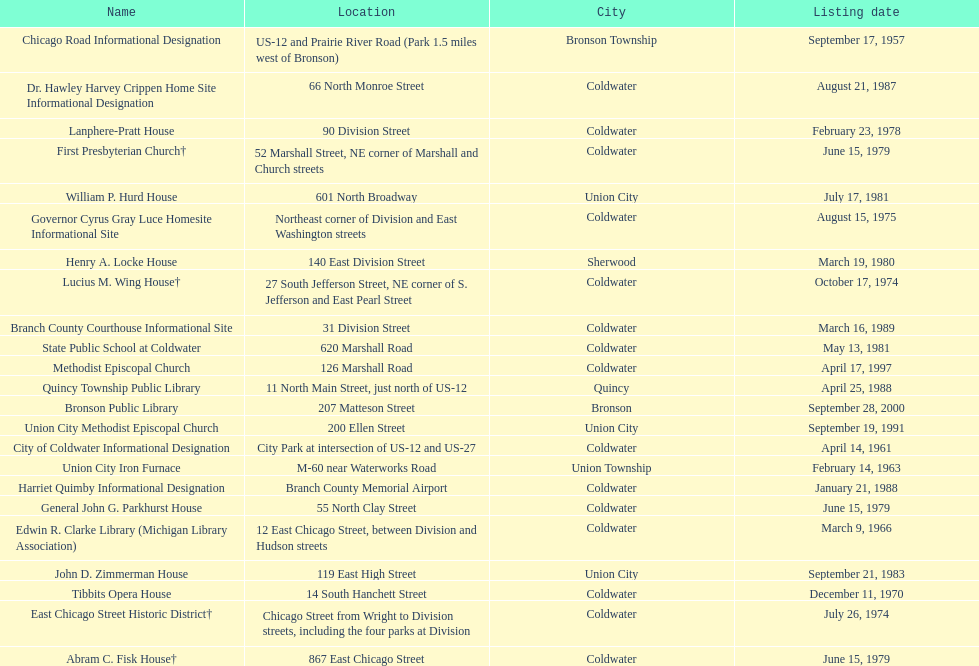Can you give me this table as a dict? {'header': ['Name', 'Location', 'City', 'Listing date'], 'rows': [['Chicago Road Informational Designation', 'US-12 and Prairie River Road (Park 1.5 miles west of Bronson)', 'Bronson Township', 'September 17, 1957'], ['Dr. Hawley Harvey Crippen Home Site Informational Designation', '66 North Monroe Street', 'Coldwater', 'August 21, 1987'], ['Lanphere-Pratt House', '90 Division Street', 'Coldwater', 'February 23, 1978'], ['First Presbyterian Church†', '52 Marshall Street, NE corner of Marshall and Church streets', 'Coldwater', 'June 15, 1979'], ['William P. Hurd House', '601 North Broadway', 'Union City', 'July 17, 1981'], ['Governor Cyrus Gray Luce Homesite Informational Site', 'Northeast corner of Division and East Washington streets', 'Coldwater', 'August 15, 1975'], ['Henry A. Locke House', '140 East Division Street', 'Sherwood', 'March 19, 1980'], ['Lucius M. Wing House†', '27 South Jefferson Street, NE corner of S. Jefferson and East Pearl Street', 'Coldwater', 'October 17, 1974'], ['Branch County Courthouse Informational Site', '31 Division Street', 'Coldwater', 'March 16, 1989'], ['State Public School at Coldwater', '620 Marshall Road', 'Coldwater', 'May 13, 1981'], ['Methodist Episcopal Church', '126 Marshall Road', 'Coldwater', 'April 17, 1997'], ['Quincy Township Public Library', '11 North Main Street, just north of US-12', 'Quincy', 'April 25, 1988'], ['Bronson Public Library', '207 Matteson Street', 'Bronson', 'September 28, 2000'], ['Union City Methodist Episcopal Church', '200 Ellen Street', 'Union City', 'September 19, 1991'], ['City of Coldwater Informational Designation', 'City Park at intersection of US-12 and US-27', 'Coldwater', 'April 14, 1961'], ['Union City Iron Furnace', 'M-60 near Waterworks Road', 'Union Township', 'February 14, 1963'], ['Harriet Quimby Informational Designation', 'Branch County Memorial Airport', 'Coldwater', 'January 21, 1988'], ['General John G. Parkhurst House', '55 North Clay Street', 'Coldwater', 'June 15, 1979'], ['Edwin R. Clarke Library (Michigan Library Association)', '12 East Chicago Street, between Division and Hudson streets', 'Coldwater', 'March 9, 1966'], ['John D. Zimmerman House', '119 East High Street', 'Union City', 'September 21, 1983'], ['Tibbits Opera House', '14 South Hanchett Street', 'Coldwater', 'December 11, 1970'], ['East Chicago Street Historic District†', 'Chicago Street from Wright to Division streets, including the four parks at Division', 'Coldwater', 'July 26, 1974'], ['Abram C. Fisk House†', '867 East Chicago Street', 'Coldwater', 'June 15, 1979']]} What is the total current listing of names on this chart? 23. 